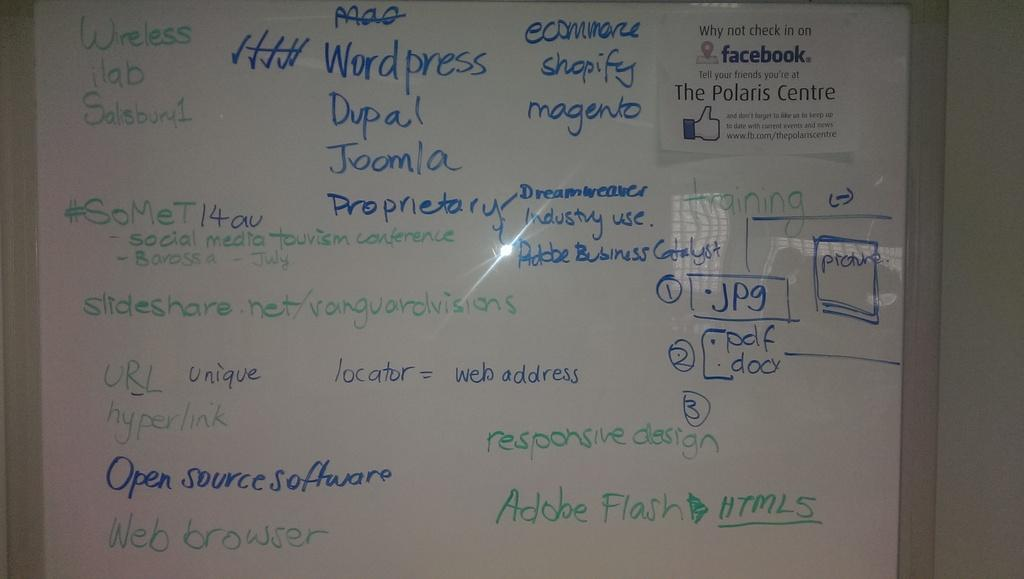Provide a one-sentence caption for the provided image. The teacher puts up programming notes on the whiteboard for his students. 